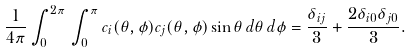Convert formula to latex. <formula><loc_0><loc_0><loc_500><loc_500>\frac { 1 } { 4 \pi } \int _ { 0 } ^ { 2 \pi } \, \int _ { 0 } ^ { \pi } c _ { i } ( \theta , \phi ) c _ { j } ( \theta , \phi ) \sin { \theta } \, d \theta \, d \phi = \frac { \delta _ { i j } } { 3 } + \frac { 2 \delta _ { i 0 } \delta _ { j 0 } } { 3 } .</formula> 